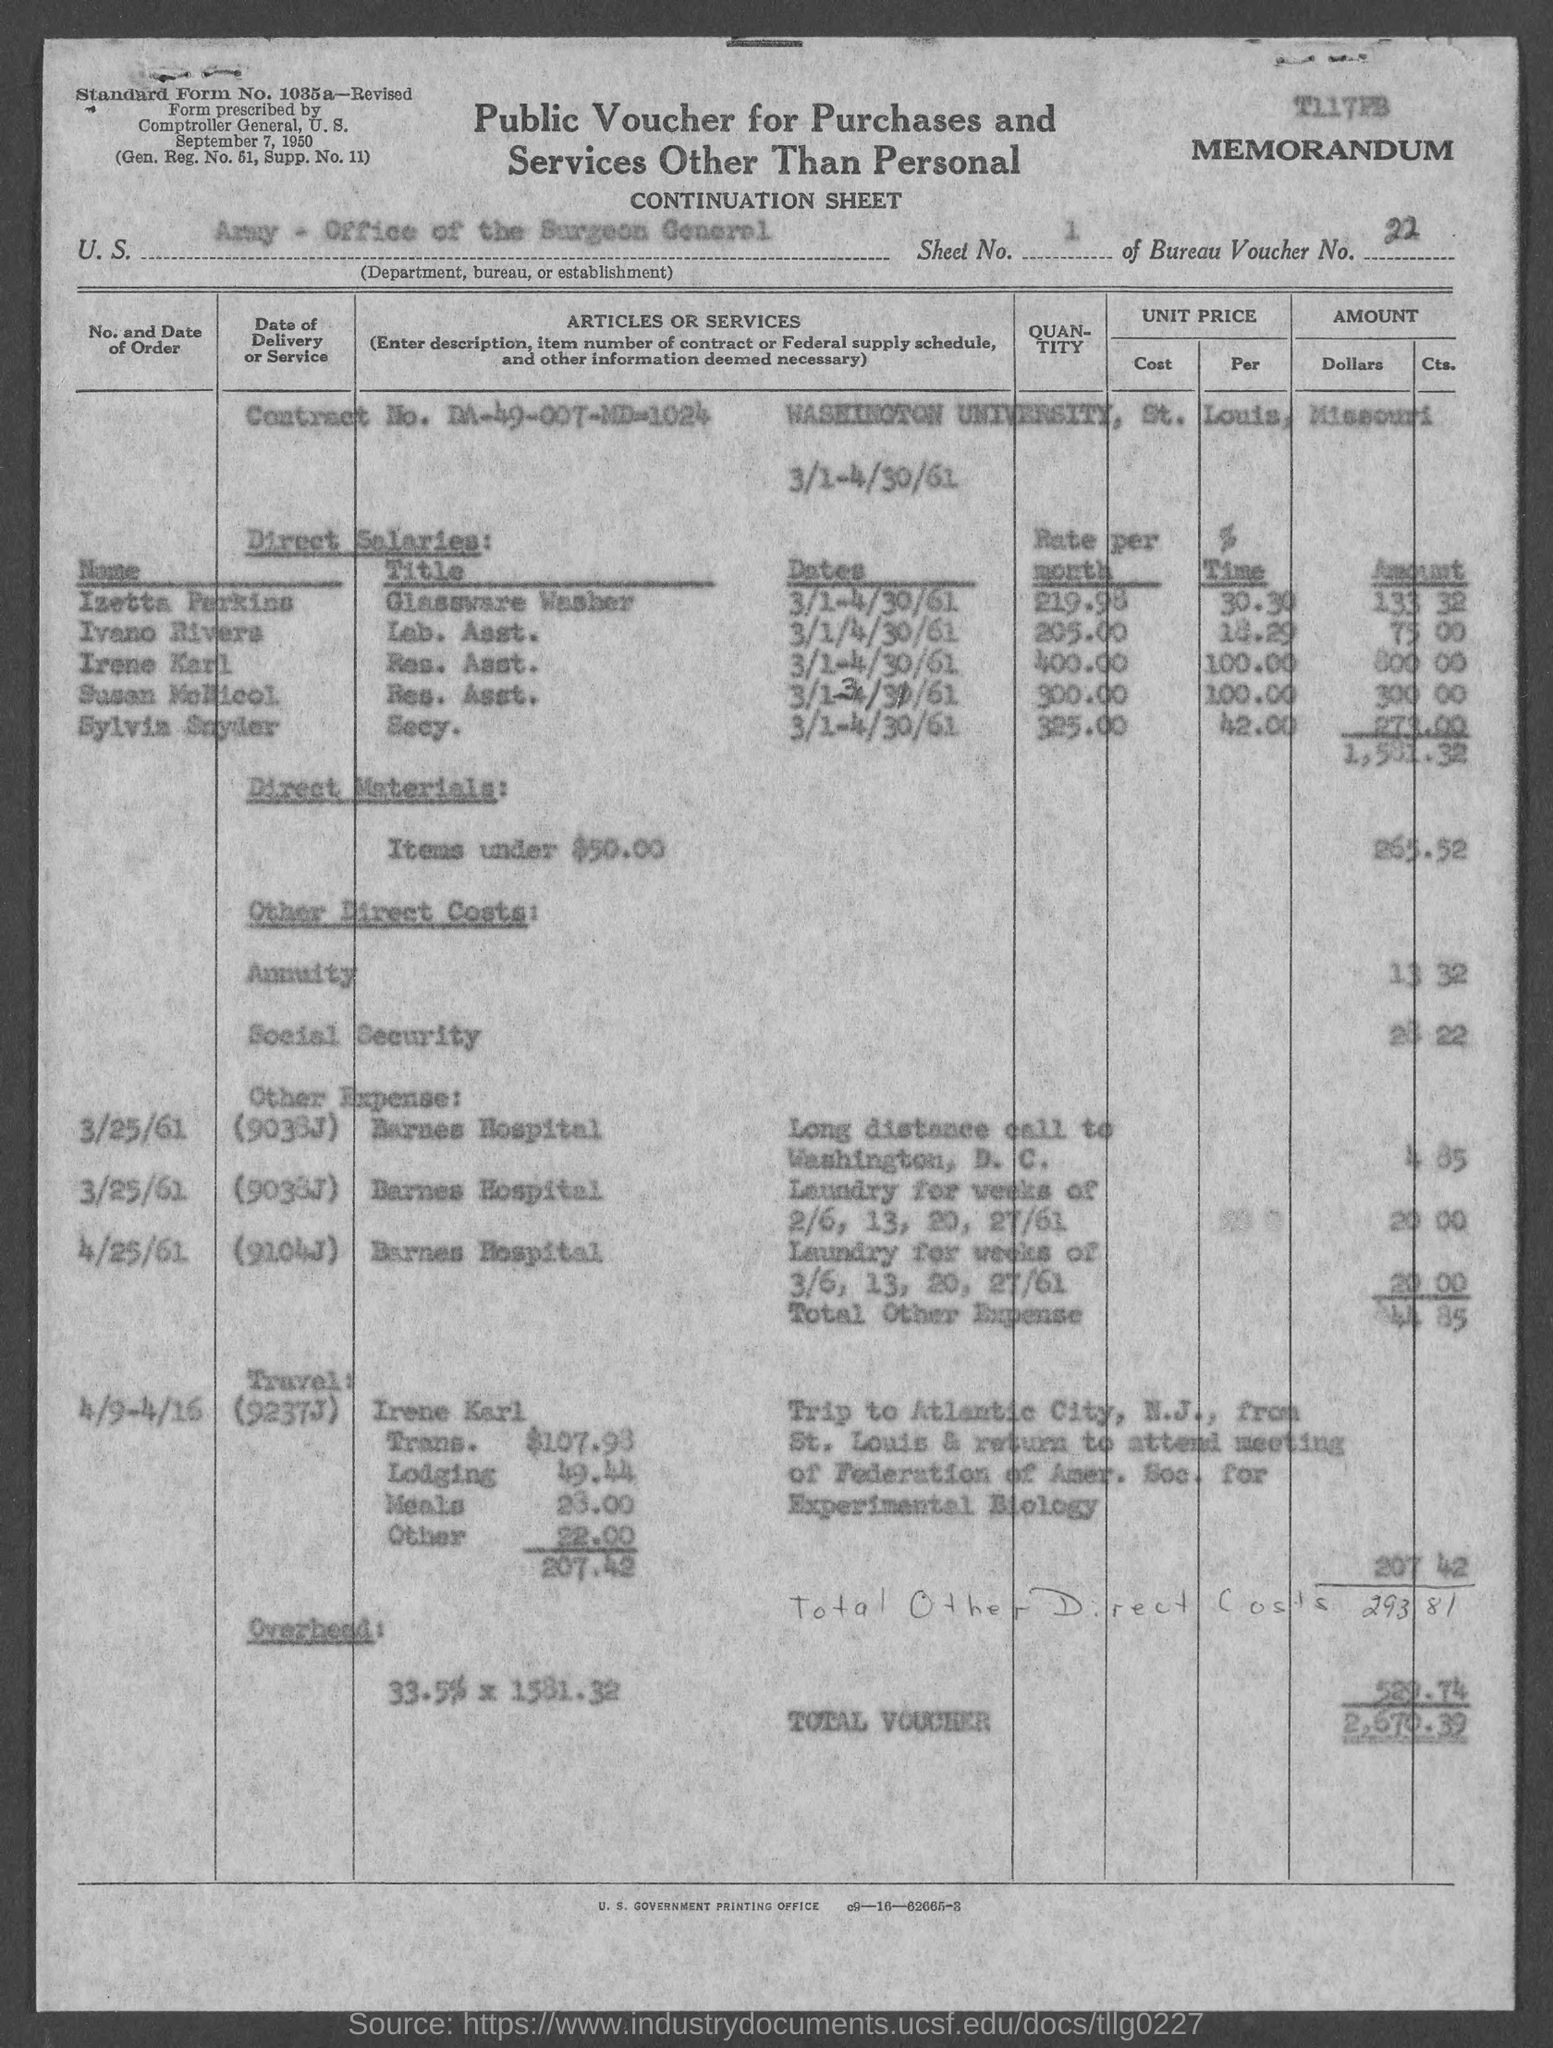Highlight a few significant elements in this photo. The sheet number is 1, starting from 1. The contract number is DA-49-007-MD-1024. I am requesting information about a specific bureau voucher number, which is 22... The total voucher amount is 2,670.39. 